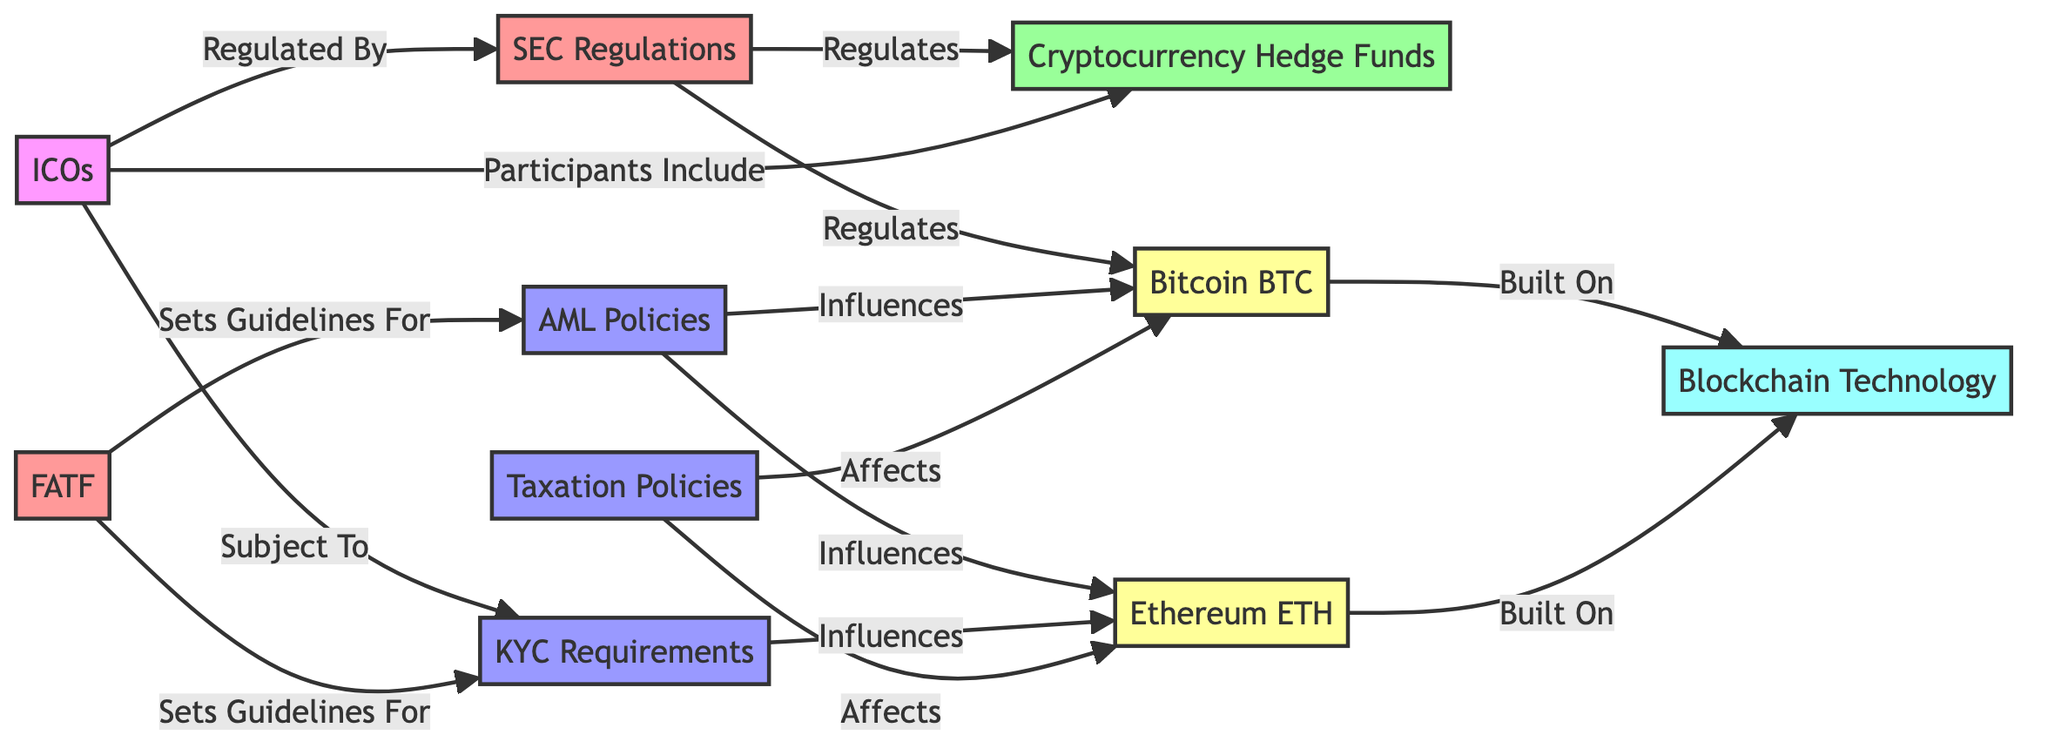What is the total number of nodes in the diagram? The diagram contains ten distinct entities: SEC Regulations, Cryptocurrency Hedge Funds, Anti-Money Laundering Policies, Bitcoin, Initial Coin Offerings, Blockchain Technology, Know Your Customer Requirements, Financial Action Task Force, Ethereum, and Taxation Policies. Counting these gives a total of ten nodes.
Answer: 10 Which entity is regulated by the SEC? From the diagram, there is an arrow labeled "Regulates" pointing from SEC Regulations to Bitcoin, which indicates Bitcoin is subject to regulation by the SEC.
Answer: Bitcoin How many regulatory policies are shown in the diagram? The diagram includes three regulatory policies: Anti-Money Laundering Policies, Know Your Customer Requirements, and Taxation Policies. By counting these policies, we find there are three in total.
Answer: 3 Which cryptocurrency is influenced by Anti-Money Laundering Policies? Based on the relationships in the diagram, there are arrows labeled "Influences" from Anti-Money Laundering Policies to both Bitcoin and Ethereum. This means both cryptocurrencies are influenced by these policies, but the question specifies Ethereum, based on the link that specifically shows influence.
Answer: Ethereum What is the relationship between ICOs and KYC Requirements? The diagram illustrates that Initial Coin Offerings are "Subject To" KYC Requirements. This indicates a direct regulatory relationship where ICOs must comply with KYC policies.
Answer: Subject To Which regulatory body sets guidelines for AML Policies? According to the diagram, the Financial Action Task Force has an arrow labeled "Sets Guidelines For" that points to Anti-Money Laundering Policies. This indicates the FATF is the body responsible for setting these guidelines.
Answer: Financial Action Task Force What is the underlying technology for Bitcoin and Ethereum? The diagram shows both Bitcoin and Ethereum indicated as "Built On" Blockchain Technology. The presence of the same label for both indicates that Blockchain Technology serves as the underlying technology for both cryptocurrencies.
Answer: Blockchain Technology How do taxation policies affect cryptocurrency? The diagram states that Taxation Policies "Affects" both Bitcoin and Ethereum, meaning these policies have a significant impact on the performance or regulatory environment of these cryptocurrencies.
Answer: Affects Which market activity includes cryptocurrency hedge funds as participants? The diagram indicates a relationship where Initial Coin Offerings include Cryptocurrency Hedge Funds as participants, showing a direct connection.
Answer: ICOs 